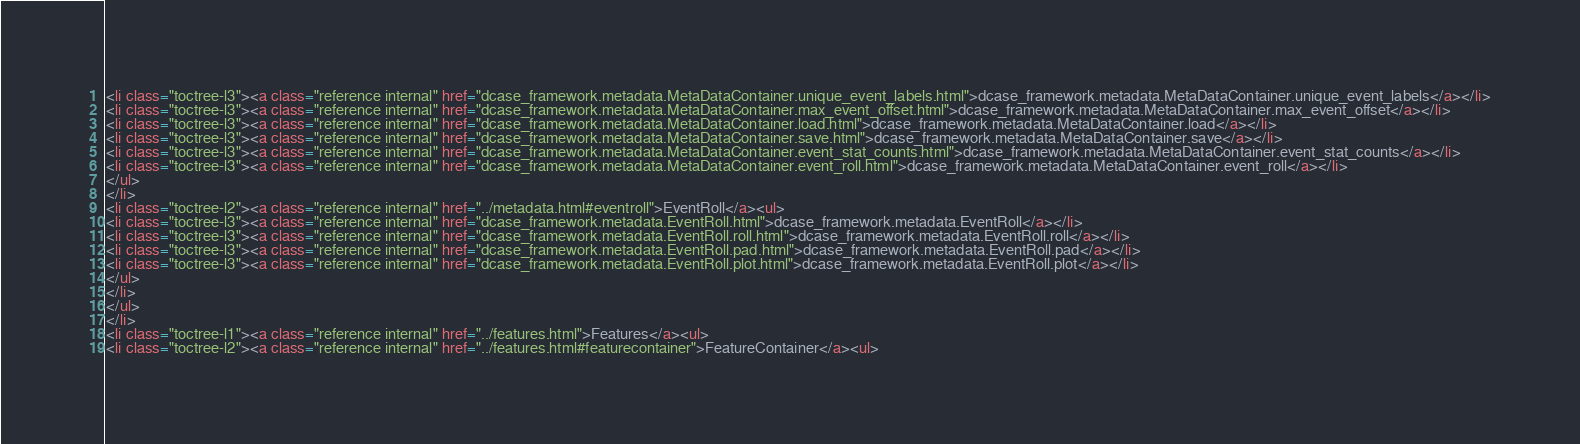Convert code to text. <code><loc_0><loc_0><loc_500><loc_500><_HTML_><li class="toctree-l3"><a class="reference internal" href="dcase_framework.metadata.MetaDataContainer.unique_event_labels.html">dcase_framework.metadata.MetaDataContainer.unique_event_labels</a></li>
<li class="toctree-l3"><a class="reference internal" href="dcase_framework.metadata.MetaDataContainer.max_event_offset.html">dcase_framework.metadata.MetaDataContainer.max_event_offset</a></li>
<li class="toctree-l3"><a class="reference internal" href="dcase_framework.metadata.MetaDataContainer.load.html">dcase_framework.metadata.MetaDataContainer.load</a></li>
<li class="toctree-l3"><a class="reference internal" href="dcase_framework.metadata.MetaDataContainer.save.html">dcase_framework.metadata.MetaDataContainer.save</a></li>
<li class="toctree-l3"><a class="reference internal" href="dcase_framework.metadata.MetaDataContainer.event_stat_counts.html">dcase_framework.metadata.MetaDataContainer.event_stat_counts</a></li>
<li class="toctree-l3"><a class="reference internal" href="dcase_framework.metadata.MetaDataContainer.event_roll.html">dcase_framework.metadata.MetaDataContainer.event_roll</a></li>
</ul>
</li>
<li class="toctree-l2"><a class="reference internal" href="../metadata.html#eventroll">EventRoll</a><ul>
<li class="toctree-l3"><a class="reference internal" href="dcase_framework.metadata.EventRoll.html">dcase_framework.metadata.EventRoll</a></li>
<li class="toctree-l3"><a class="reference internal" href="dcase_framework.metadata.EventRoll.roll.html">dcase_framework.metadata.EventRoll.roll</a></li>
<li class="toctree-l3"><a class="reference internal" href="dcase_framework.metadata.EventRoll.pad.html">dcase_framework.metadata.EventRoll.pad</a></li>
<li class="toctree-l3"><a class="reference internal" href="dcase_framework.metadata.EventRoll.plot.html">dcase_framework.metadata.EventRoll.plot</a></li>
</ul>
</li>
</ul>
</li>
<li class="toctree-l1"><a class="reference internal" href="../features.html">Features</a><ul>
<li class="toctree-l2"><a class="reference internal" href="../features.html#featurecontainer">FeatureContainer</a><ul></code> 